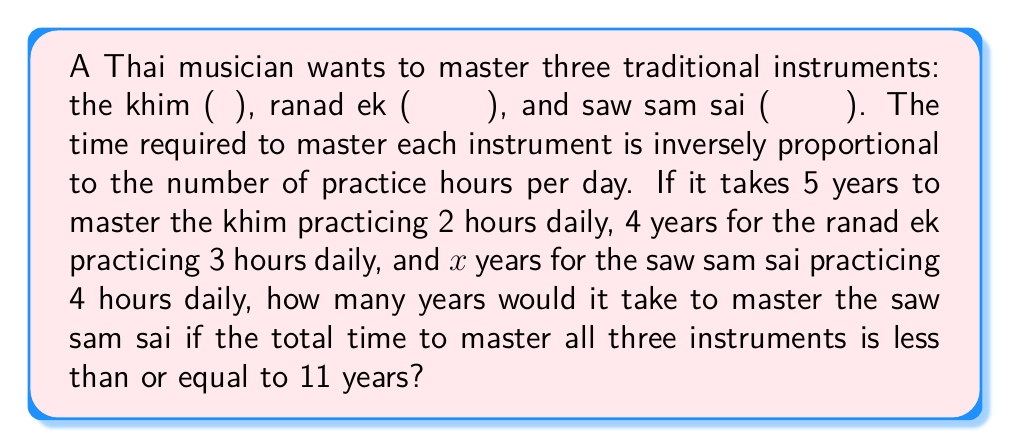What is the answer to this math problem? Let's approach this step-by-step:

1) Let's define the relationship between time and practice hours:
   $T_1 \cdot H_1 = T_2 \cdot H_2$, where T is time and H is hours practiced per day

2) For the khim: $5 \cdot 2 = 10$ (time-practice constant)
   For the ranad ek: $4 \cdot 3 = 12$ (time-practice constant)

3) Let x be the time to master the saw sam sai. Then:
   $x \cdot 4 = 12$ (assuming the same time-practice constant as ranad ek)

4) Solving for x:
   $x = 12 / 4 = 3$ years

5) Now, we need to check if the total time is less than or equal to 11 years:
   $5 + 4 + x \leq 11$
   $9 + x \leq 11$
   $x \leq 2$

6) Since our calculated x (3) is greater than 2, we need to find the maximum value of x that satisfies the inequality:
   $x = 11 - 9 = 2$

Therefore, to satisfy the condition that the total time is less than or equal to 11 years, it would take at most 2 years to master the saw sam sai.
Answer: 2 years 